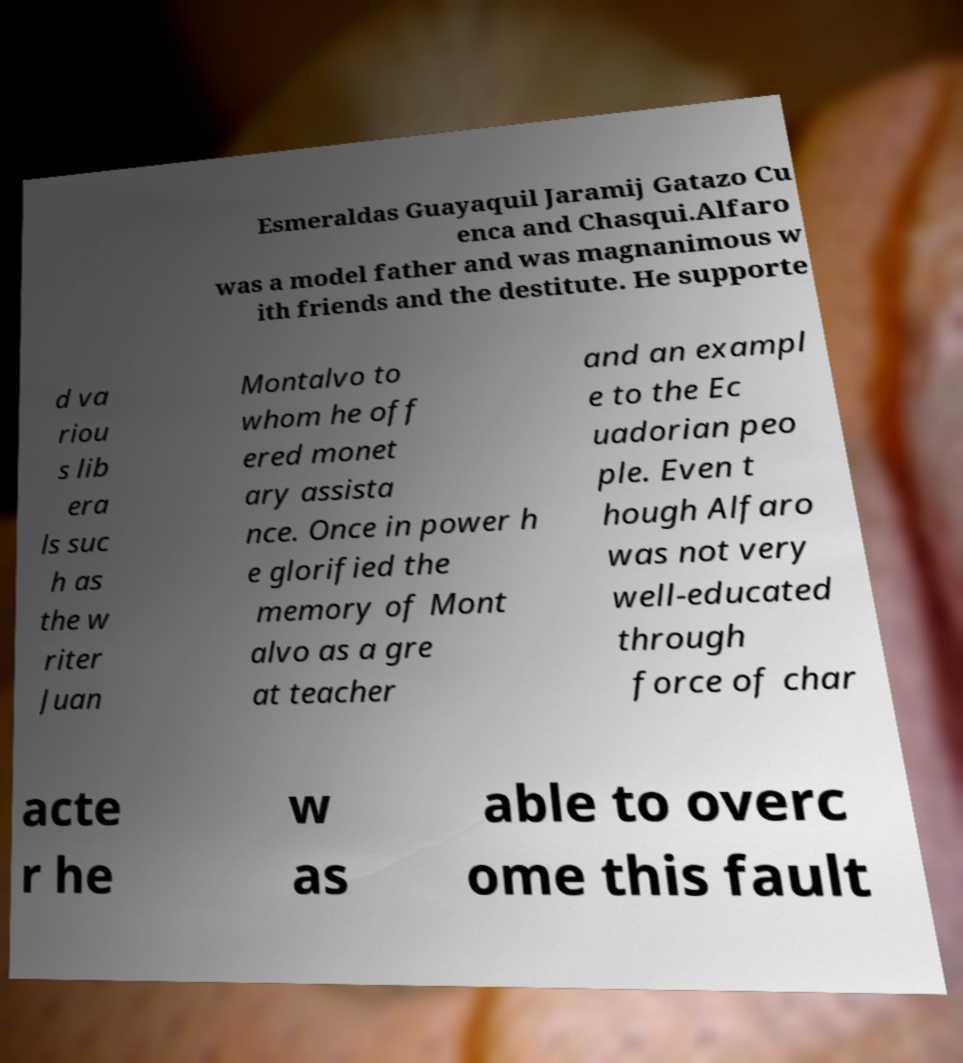For documentation purposes, I need the text within this image transcribed. Could you provide that? Esmeraldas Guayaquil Jaramij Gatazo Cu enca and Chasqui.Alfaro was a model father and was magnanimous w ith friends and the destitute. He supporte d va riou s lib era ls suc h as the w riter Juan Montalvo to whom he off ered monet ary assista nce. Once in power h e glorified the memory of Mont alvo as a gre at teacher and an exampl e to the Ec uadorian peo ple. Even t hough Alfaro was not very well-educated through force of char acte r he w as able to overc ome this fault 